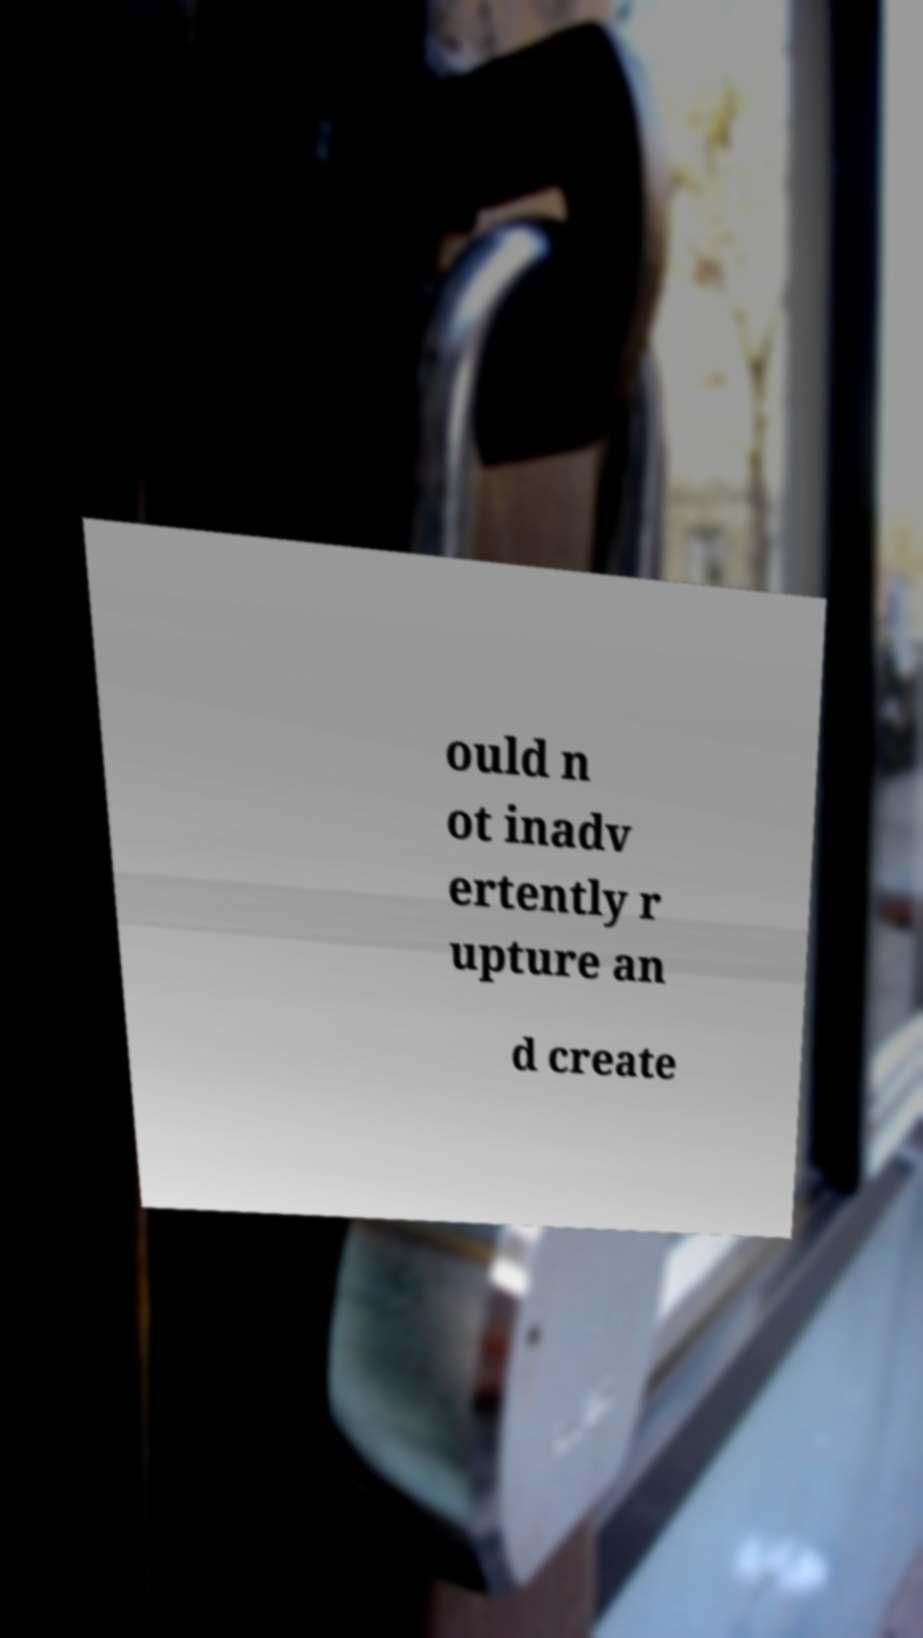I need the written content from this picture converted into text. Can you do that? ould n ot inadv ertently r upture an d create 